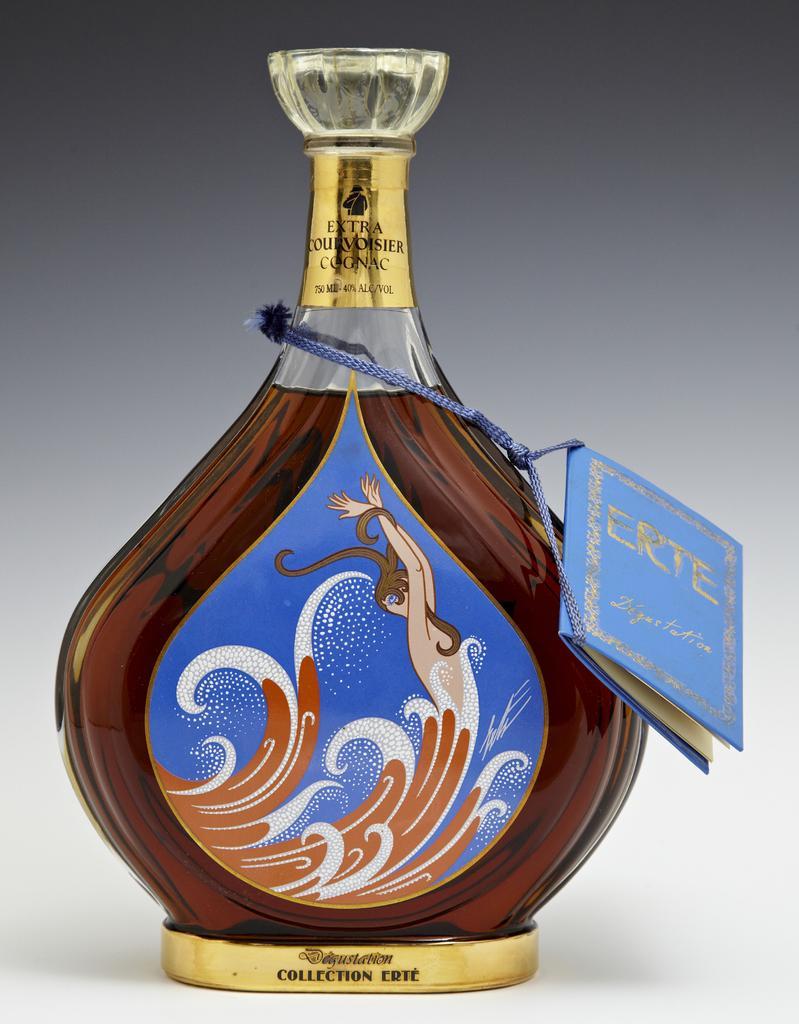Could you give a brief overview of what you see in this image? this picture shows a bottle with a tag on it. 